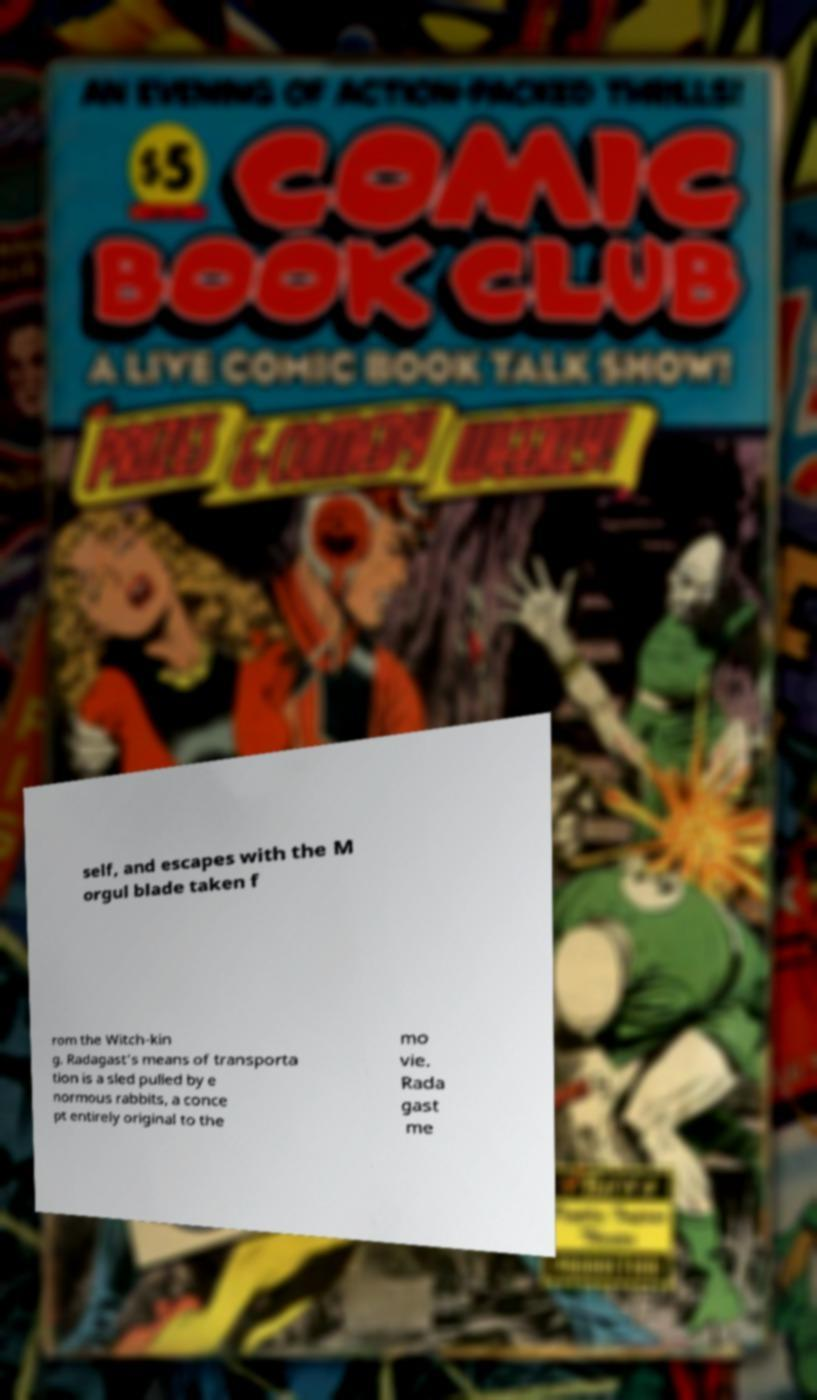Please identify and transcribe the text found in this image. self, and escapes with the M orgul blade taken f rom the Witch-kin g. Radagast's means of transporta tion is a sled pulled by e normous rabbits, a conce pt entirely original to the mo vie. Rada gast me 